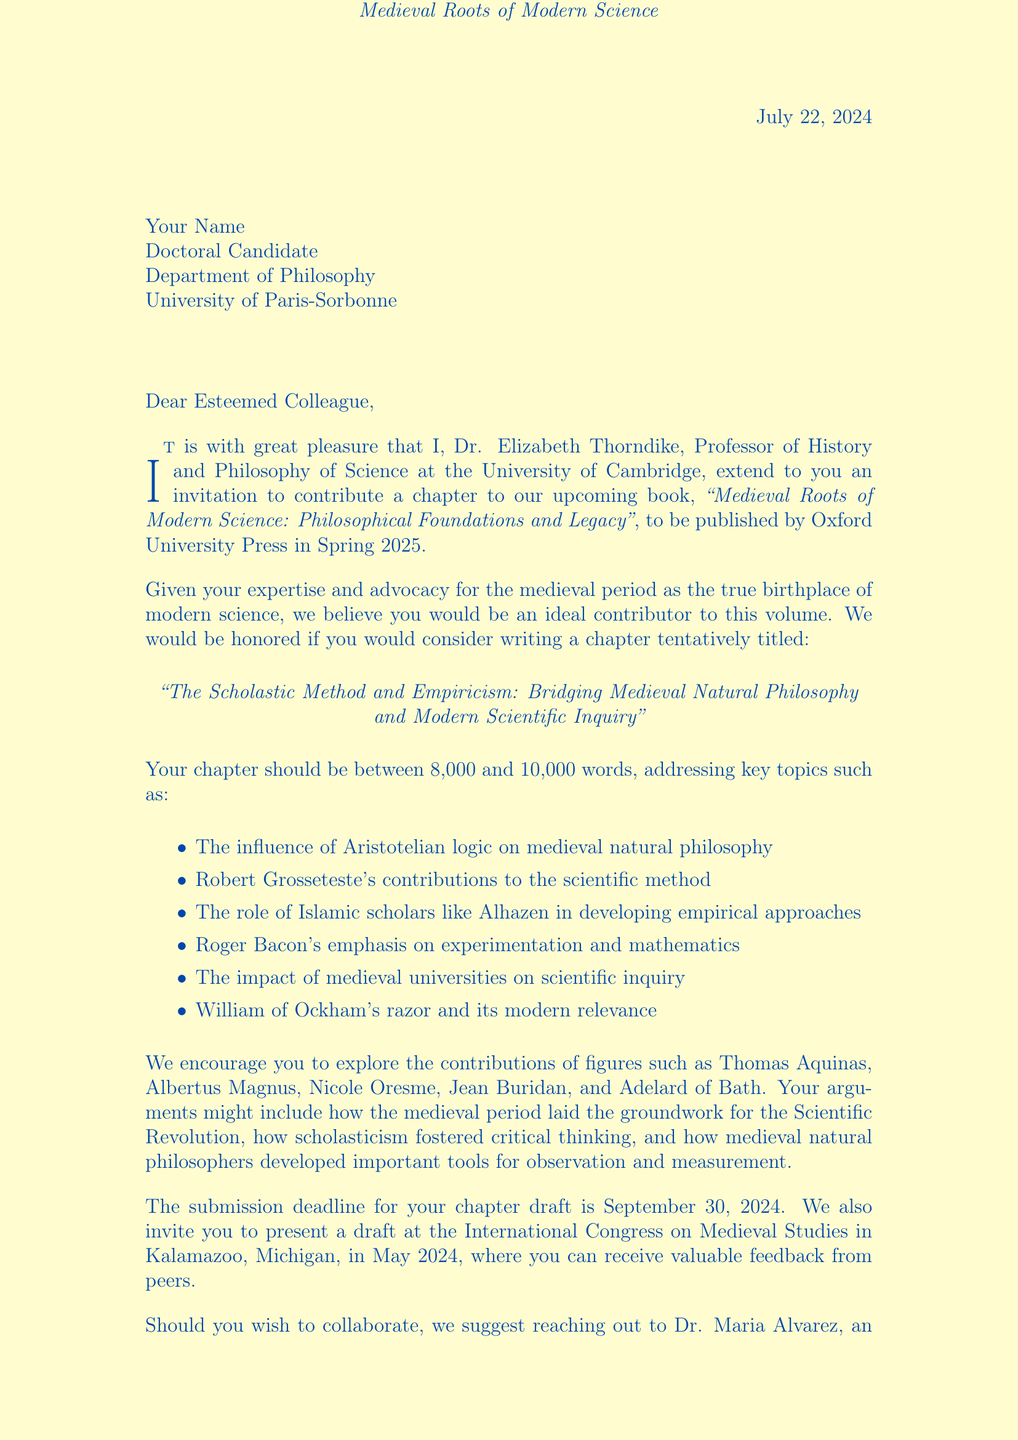What is the title of the book? The title of the book is stated in the document as "Medieval Roots of Modern Science: Philosophical Foundations and Legacy."
Answer: Medieval Roots of Modern Science: Philosophical Foundations and Legacy Who is the editor of the book? The editor is mentioned directly in the document as Dr. Elizabeth Thorndike.
Answer: Dr. Elizabeth Thorndike What is the submission deadline for the chapter? The submission deadline is clearly stated in the invitation as September 30, 2024.
Answer: September 30, 2024 What is the suggested word count for the chapter? The document specifies that the chapter should be between 8,000 and 10,000 words.
Answer: 8,000-10,000 words Where will the International Congress on Medieval Studies take place? The location of the conference is indicated in the document as Kalamazoo, Michigan.
Answer: Kalamazoo, Michigan What key philosophical figure is specifically mentioned in relation to modern scientific thinking? The document notes William of Ockham's razor and its modern relevance.
Answer: William of Ockham Which university is Dr. Elizabeth Thorndike affiliated with? Dr. Elizabeth Thorndike is affiliated with the University of Cambridge, as mentioned in the document.
Answer: University of Cambridge What opportunity does the invitation offer besides writing a chapter? The invitation offers the opportunity to present a draft at an academic conference.
Answer: Conference presentation Which scholar's contributions to scientific method are highlighted in the chapter proposal? Robert Grosseteste's contributions are highlighted in the proposed chapter topics.
Answer: Robert Grosseteste 